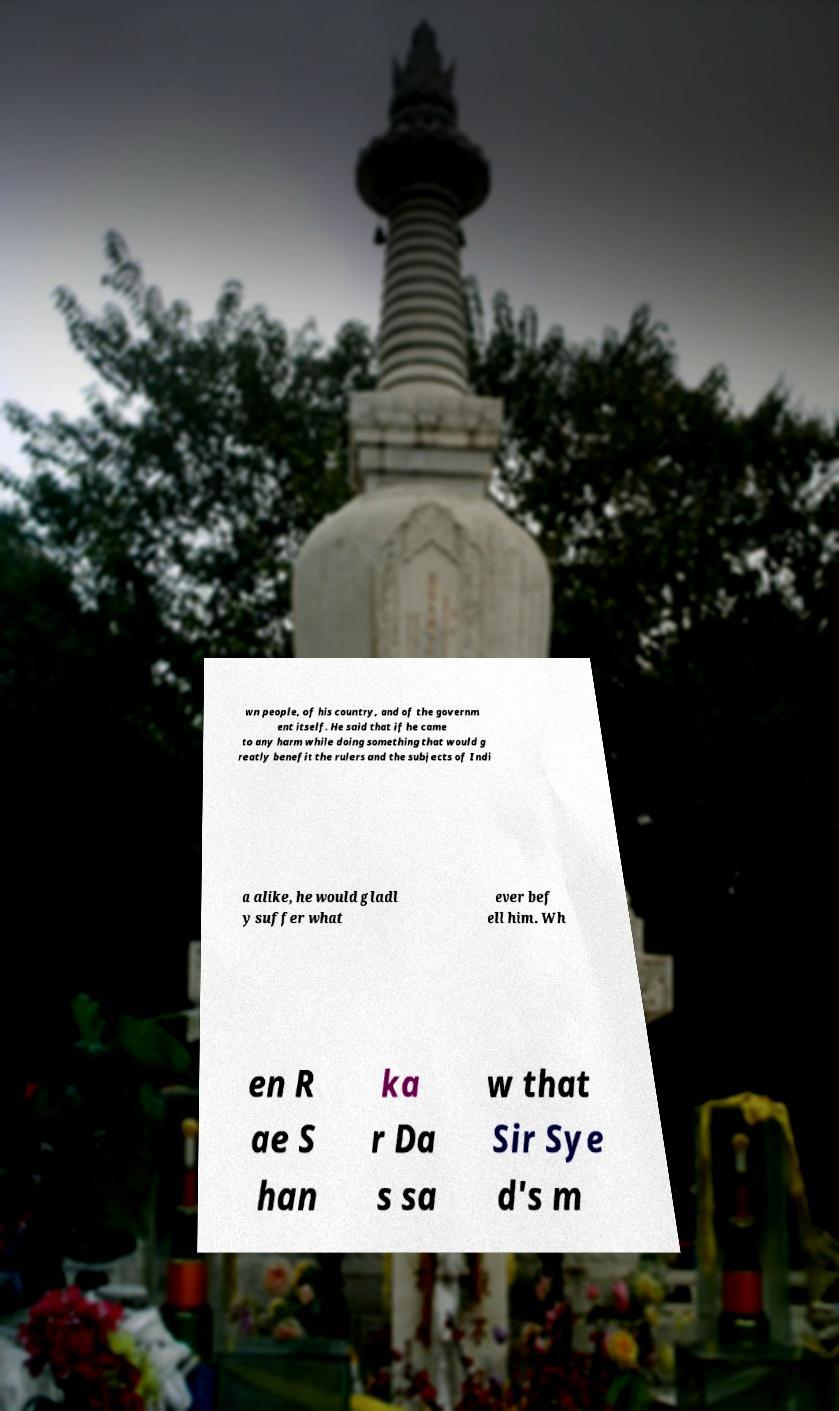Can you accurately transcribe the text from the provided image for me? wn people, of his country, and of the governm ent itself. He said that if he came to any harm while doing something that would g reatly benefit the rulers and the subjects of Indi a alike, he would gladl y suffer what ever bef ell him. Wh en R ae S han ka r Da s sa w that Sir Sye d's m 